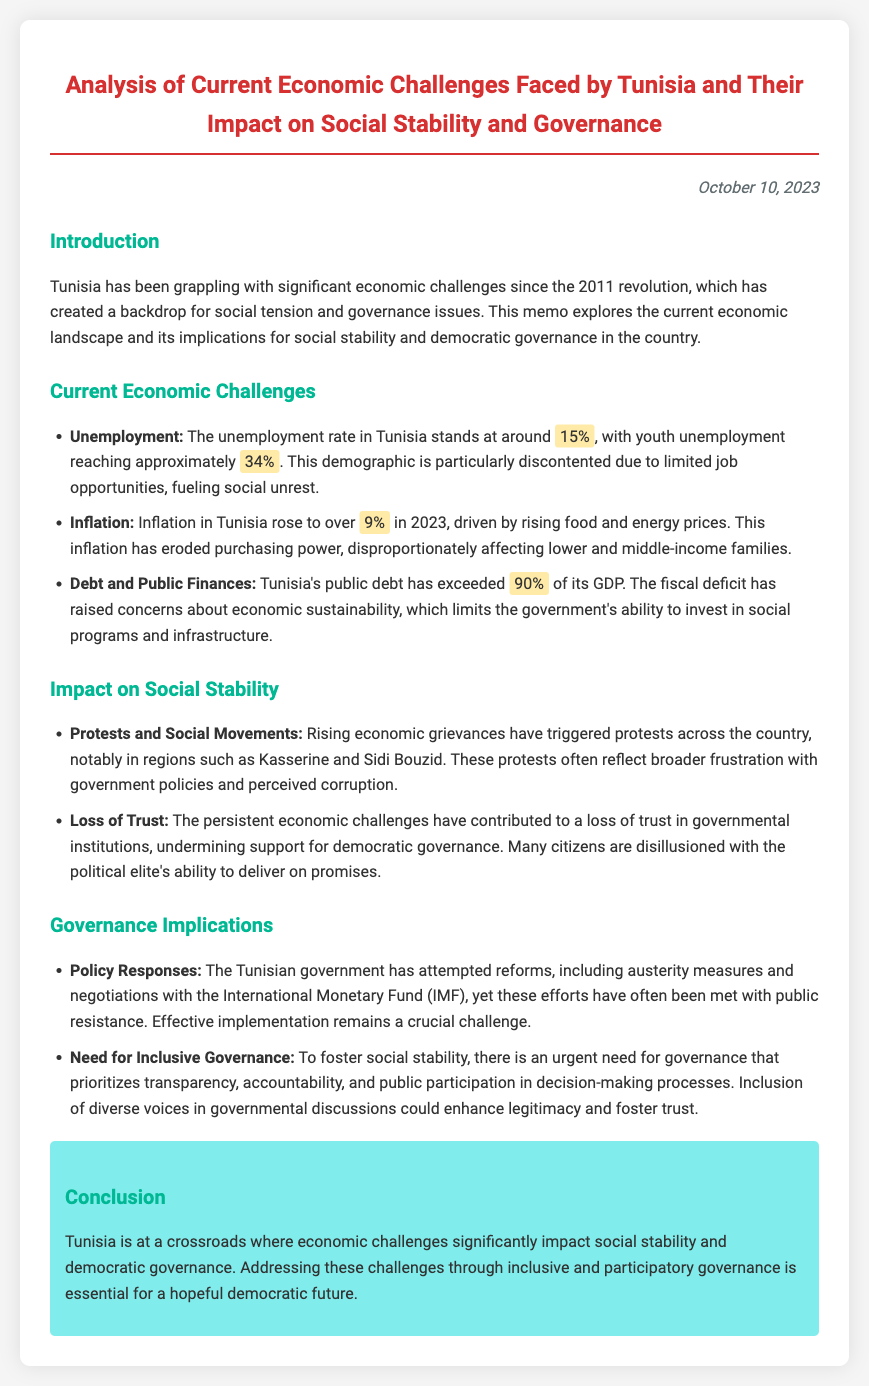What is the current unemployment rate in Tunisia? The document states that the unemployment rate in Tunisia stands at around 15%.
Answer: 15% What is the youth unemployment rate in Tunisia? The document mentions that youth unemployment reaches approximately 34%.
Answer: 34% What inflation rate was recorded in Tunisia in 2023? The memo indicates that inflation in Tunisia rose to over 9% in 2023.
Answer: 9% Which regions have seen protests due to rising economic grievances? The document notes that protests have occurred in regions such as Kasserine and Sidi Bouzid.
Answer: Kasserine and Sidi Bouzid What percentage of GDP does Tunisia's public debt exceed? The document states that Tunisia's public debt has exceeded 90% of its GDP.
Answer: 90% What approach has the Tunisian government attempted to address economic challenges? The memo outlines that the government has attempted reforms, including austerity measures and negotiations with the International Monetary Fund (IMF).
Answer: Austerity measures and negotiations with the IMF What is essential for fostering social stability according to the document? The document emphasizes the need for governance that prioritizes transparency, accountability, and public participation in decision-making processes.
Answer: Transparent and inclusive governance What do rising economic grievances reflect according to the document? The memo states that rising economic grievances reflect broader frustration with government policies and perceived corruption.
Answer: Frustration with government policies and corruption What is the conclusion regarding Tunisia's democratic future? The conclusion suggests that addressing economic challenges through inclusive governance is essential for a hopeful democratic future.
Answer: A hopeful democratic future 